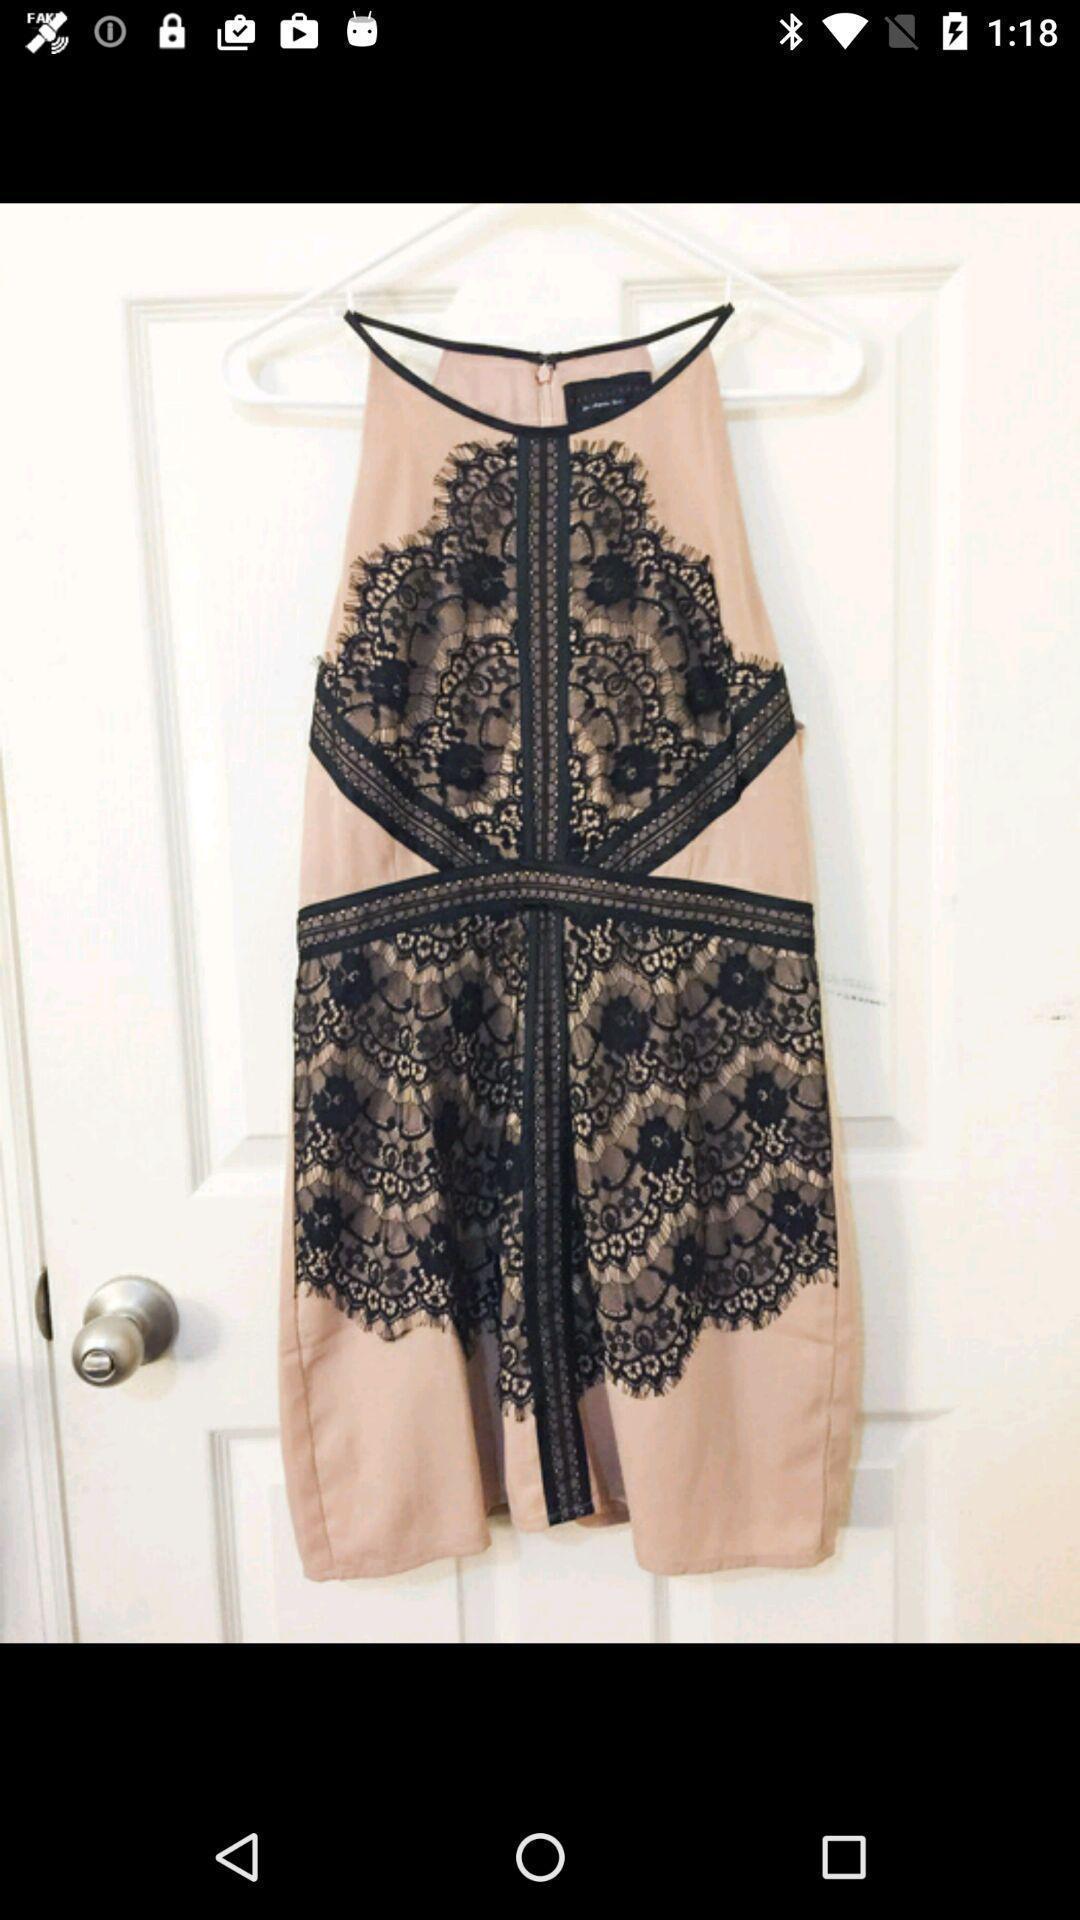Describe the visual elements of this screenshot. Screen shows image of a dress. 